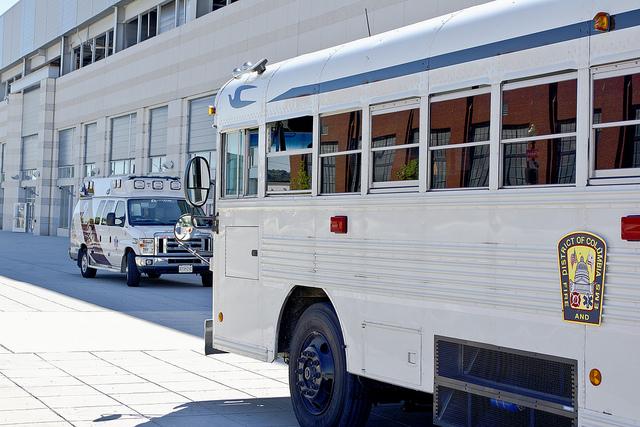What color is the bus?
Keep it brief. White. Is there a reflection in the scene?
Keep it brief. Yes. Is there a bird icon?
Answer briefly. Yes. 